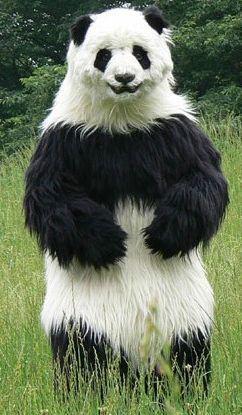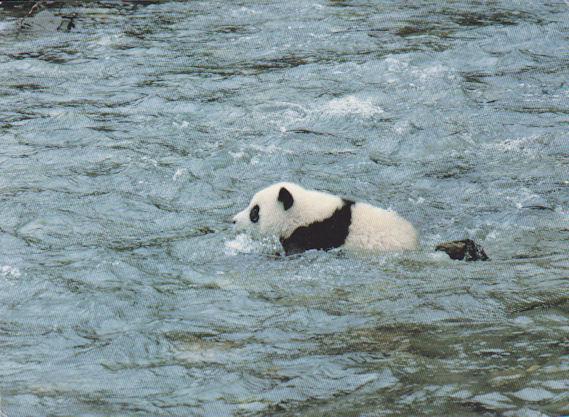The first image is the image on the left, the second image is the image on the right. Analyze the images presented: Is the assertion "One panda is in calm water." valid? Answer yes or no. No. The first image is the image on the left, the second image is the image on the right. For the images shown, is this caption "At least one image shows a panda in water near a rock formation." true? Answer yes or no. No. 